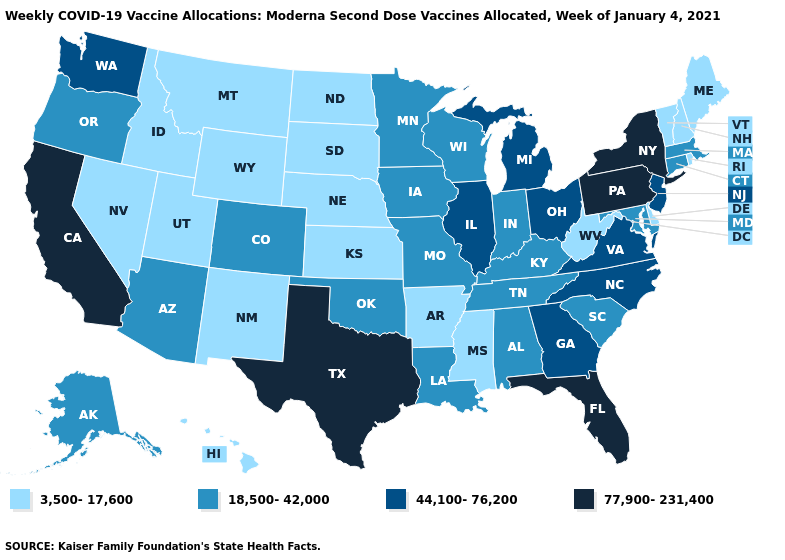What is the value of Rhode Island?
Give a very brief answer. 3,500-17,600. Does the first symbol in the legend represent the smallest category?
Write a very short answer. Yes. Name the states that have a value in the range 77,900-231,400?
Be succinct. California, Florida, New York, Pennsylvania, Texas. What is the value of New Mexico?
Short answer required. 3,500-17,600. What is the value of South Dakota?
Answer briefly. 3,500-17,600. Does Ohio have the lowest value in the MidWest?
Give a very brief answer. No. What is the value of Rhode Island?
Concise answer only. 3,500-17,600. What is the value of Missouri?
Write a very short answer. 18,500-42,000. What is the highest value in the West ?
Be succinct. 77,900-231,400. Among the states that border Connecticut , does Rhode Island have the highest value?
Answer briefly. No. Name the states that have a value in the range 44,100-76,200?
Give a very brief answer. Georgia, Illinois, Michigan, New Jersey, North Carolina, Ohio, Virginia, Washington. Does Nevada have the same value as Virginia?
Concise answer only. No. How many symbols are there in the legend?
Concise answer only. 4. What is the value of North Dakota?
Write a very short answer. 3,500-17,600. Does Ohio have the highest value in the MidWest?
Give a very brief answer. Yes. 